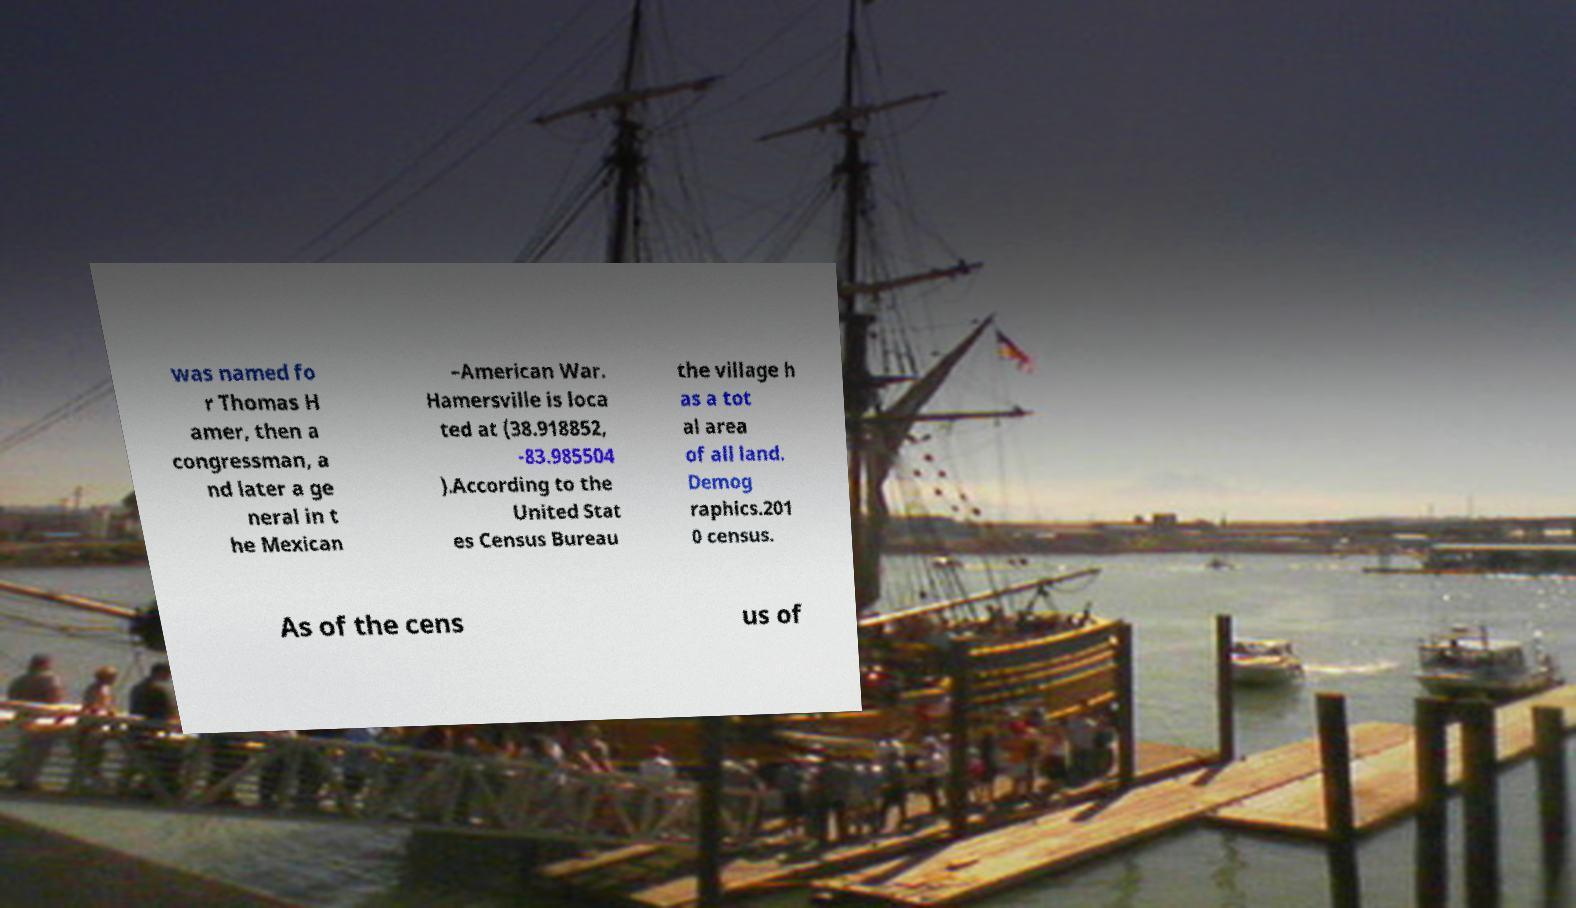For documentation purposes, I need the text within this image transcribed. Could you provide that? was named fo r Thomas H amer, then a congressman, a nd later a ge neral in t he Mexican –American War. Hamersville is loca ted at (38.918852, -83.985504 ).According to the United Stat es Census Bureau the village h as a tot al area of all land. Demog raphics.201 0 census. As of the cens us of 